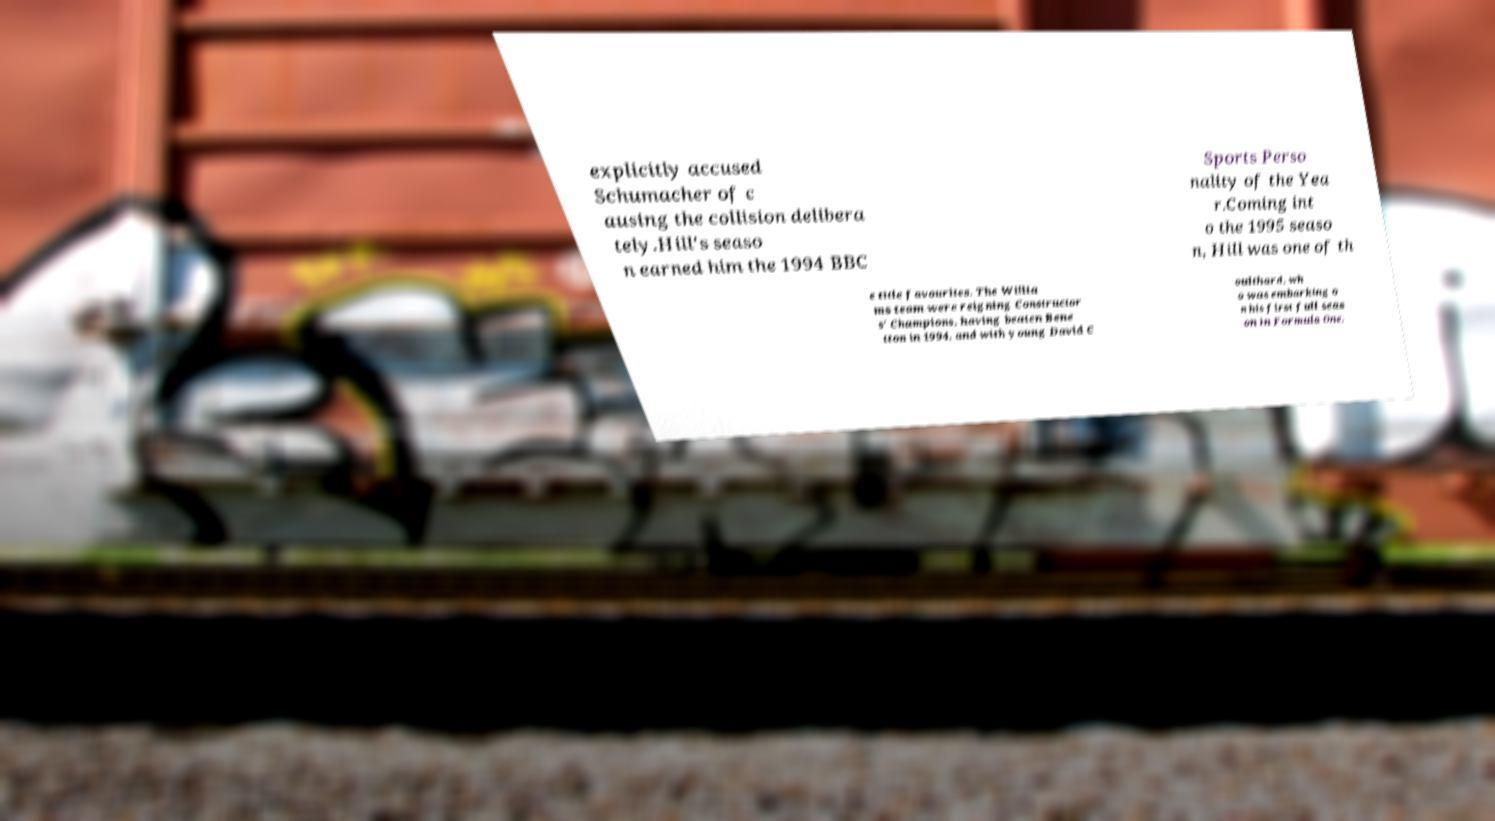Can you read and provide the text displayed in the image?This photo seems to have some interesting text. Can you extract and type it out for me? explicitly accused Schumacher of c ausing the collision delibera tely.Hill's seaso n earned him the 1994 BBC Sports Perso nality of the Yea r.Coming int o the 1995 seaso n, Hill was one of th e title favourites. The Willia ms team were reigning Constructor s' Champions, having beaten Bene tton in 1994, and with young David C oulthard, wh o was embarking o n his first full seas on in Formula One, 